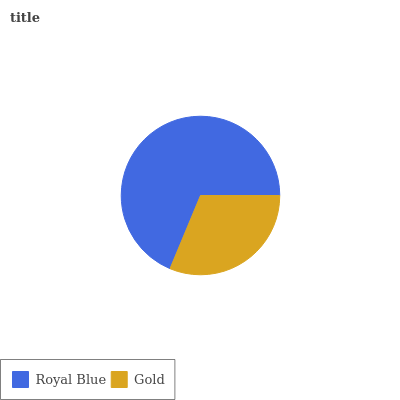Is Gold the minimum?
Answer yes or no. Yes. Is Royal Blue the maximum?
Answer yes or no. Yes. Is Gold the maximum?
Answer yes or no. No. Is Royal Blue greater than Gold?
Answer yes or no. Yes. Is Gold less than Royal Blue?
Answer yes or no. Yes. Is Gold greater than Royal Blue?
Answer yes or no. No. Is Royal Blue less than Gold?
Answer yes or no. No. Is Royal Blue the high median?
Answer yes or no. Yes. Is Gold the low median?
Answer yes or no. Yes. Is Gold the high median?
Answer yes or no. No. Is Royal Blue the low median?
Answer yes or no. No. 